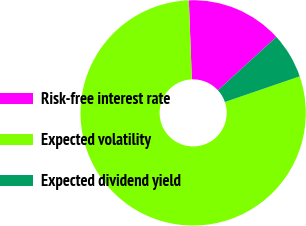Convert chart to OTSL. <chart><loc_0><loc_0><loc_500><loc_500><pie_chart><fcel>Risk-free interest rate<fcel>Expected volatility<fcel>Expected dividend yield<nl><fcel>13.83%<fcel>79.65%<fcel>6.52%<nl></chart> 